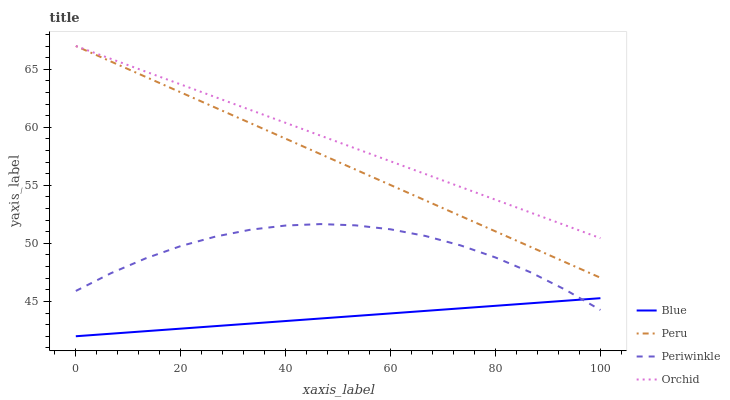Does Blue have the minimum area under the curve?
Answer yes or no. Yes. Does Orchid have the maximum area under the curve?
Answer yes or no. Yes. Does Periwinkle have the minimum area under the curve?
Answer yes or no. No. Does Periwinkle have the maximum area under the curve?
Answer yes or no. No. Is Blue the smoothest?
Answer yes or no. Yes. Is Periwinkle the roughest?
Answer yes or no. Yes. Is Peru the smoothest?
Answer yes or no. No. Is Peru the roughest?
Answer yes or no. No. Does Blue have the lowest value?
Answer yes or no. Yes. Does Periwinkle have the lowest value?
Answer yes or no. No. Does Orchid have the highest value?
Answer yes or no. Yes. Does Periwinkle have the highest value?
Answer yes or no. No. Is Blue less than Orchid?
Answer yes or no. Yes. Is Peru greater than Blue?
Answer yes or no. Yes. Does Blue intersect Periwinkle?
Answer yes or no. Yes. Is Blue less than Periwinkle?
Answer yes or no. No. Is Blue greater than Periwinkle?
Answer yes or no. No. Does Blue intersect Orchid?
Answer yes or no. No. 